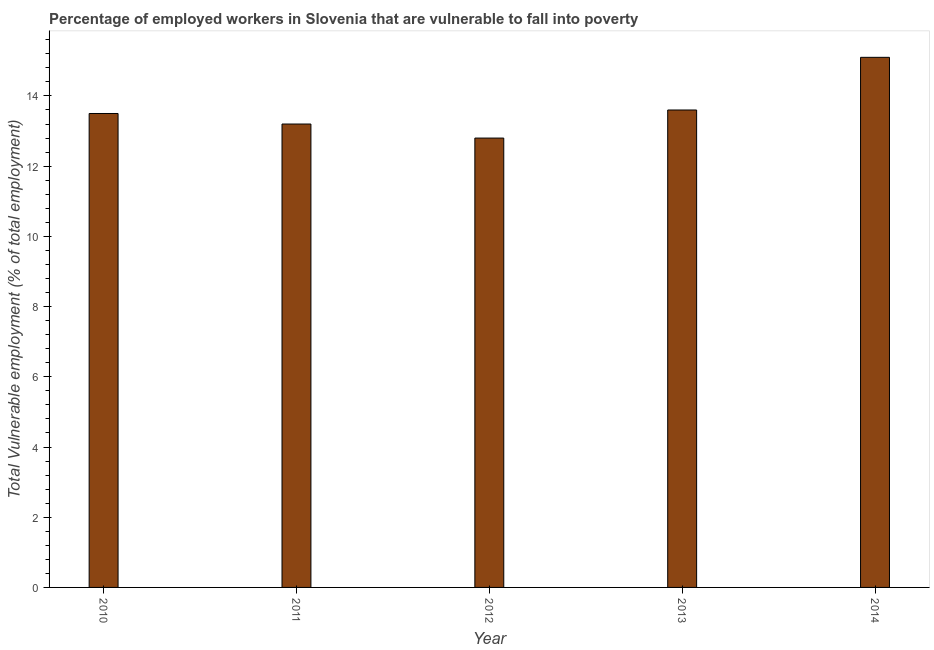Does the graph contain grids?
Ensure brevity in your answer.  No. What is the title of the graph?
Offer a terse response. Percentage of employed workers in Slovenia that are vulnerable to fall into poverty. What is the label or title of the Y-axis?
Offer a terse response. Total Vulnerable employment (% of total employment). What is the total vulnerable employment in 2014?
Your response must be concise. 15.1. Across all years, what is the maximum total vulnerable employment?
Offer a terse response. 15.1. Across all years, what is the minimum total vulnerable employment?
Provide a succinct answer. 12.8. In which year was the total vulnerable employment minimum?
Your answer should be compact. 2012. What is the sum of the total vulnerable employment?
Offer a very short reply. 68.2. What is the average total vulnerable employment per year?
Provide a succinct answer. 13.64. In how many years, is the total vulnerable employment greater than 4 %?
Give a very brief answer. 5. Do a majority of the years between 2011 and 2012 (inclusive) have total vulnerable employment greater than 3.6 %?
Give a very brief answer. Yes. What is the ratio of the total vulnerable employment in 2011 to that in 2014?
Provide a succinct answer. 0.87. Is the total vulnerable employment in 2012 less than that in 2014?
Give a very brief answer. Yes. Is the difference between the total vulnerable employment in 2010 and 2011 greater than the difference between any two years?
Your response must be concise. No. Is the sum of the total vulnerable employment in 2013 and 2014 greater than the maximum total vulnerable employment across all years?
Provide a succinct answer. Yes. In how many years, is the total vulnerable employment greater than the average total vulnerable employment taken over all years?
Provide a succinct answer. 1. How many bars are there?
Give a very brief answer. 5. What is the difference between two consecutive major ticks on the Y-axis?
Your answer should be compact. 2. Are the values on the major ticks of Y-axis written in scientific E-notation?
Ensure brevity in your answer.  No. What is the Total Vulnerable employment (% of total employment) in 2010?
Offer a terse response. 13.5. What is the Total Vulnerable employment (% of total employment) in 2011?
Offer a terse response. 13.2. What is the Total Vulnerable employment (% of total employment) in 2012?
Ensure brevity in your answer.  12.8. What is the Total Vulnerable employment (% of total employment) of 2013?
Give a very brief answer. 13.6. What is the Total Vulnerable employment (% of total employment) of 2014?
Make the answer very short. 15.1. What is the difference between the Total Vulnerable employment (% of total employment) in 2010 and 2011?
Ensure brevity in your answer.  0.3. What is the difference between the Total Vulnerable employment (% of total employment) in 2010 and 2013?
Your answer should be compact. -0.1. What is the difference between the Total Vulnerable employment (% of total employment) in 2012 and 2013?
Your response must be concise. -0.8. What is the difference between the Total Vulnerable employment (% of total employment) in 2012 and 2014?
Provide a short and direct response. -2.3. What is the ratio of the Total Vulnerable employment (% of total employment) in 2010 to that in 2012?
Make the answer very short. 1.05. What is the ratio of the Total Vulnerable employment (% of total employment) in 2010 to that in 2014?
Give a very brief answer. 0.89. What is the ratio of the Total Vulnerable employment (% of total employment) in 2011 to that in 2012?
Give a very brief answer. 1.03. What is the ratio of the Total Vulnerable employment (% of total employment) in 2011 to that in 2014?
Keep it short and to the point. 0.87. What is the ratio of the Total Vulnerable employment (% of total employment) in 2012 to that in 2013?
Make the answer very short. 0.94. What is the ratio of the Total Vulnerable employment (% of total employment) in 2012 to that in 2014?
Provide a short and direct response. 0.85. What is the ratio of the Total Vulnerable employment (% of total employment) in 2013 to that in 2014?
Ensure brevity in your answer.  0.9. 